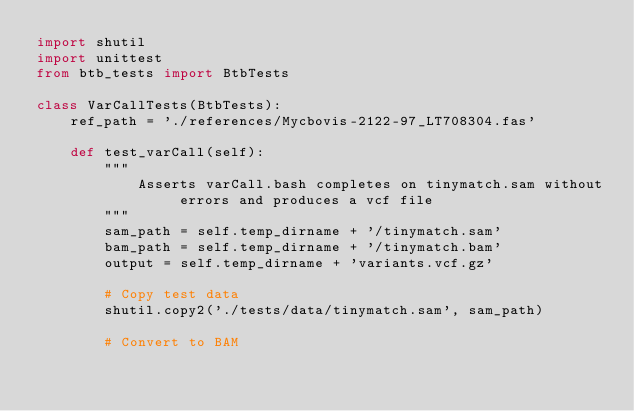Convert code to text. <code><loc_0><loc_0><loc_500><loc_500><_Python_>import shutil
import unittest
from btb_tests import BtbTests

class VarCallTests(BtbTests):
    ref_path = './references/Mycbovis-2122-97_LT708304.fas'

    def test_varCall(self):
        """
            Asserts varCall.bash completes on tinymatch.sam without errors and produces a vcf file
        """
        sam_path = self.temp_dirname + '/tinymatch.sam'
        bam_path = self.temp_dirname + '/tinymatch.bam'
        output = self.temp_dirname + 'variants.vcf.gz'

        # Copy test data
        shutil.copy2('./tests/data/tinymatch.sam', sam_path)

        # Convert to BAM</code> 